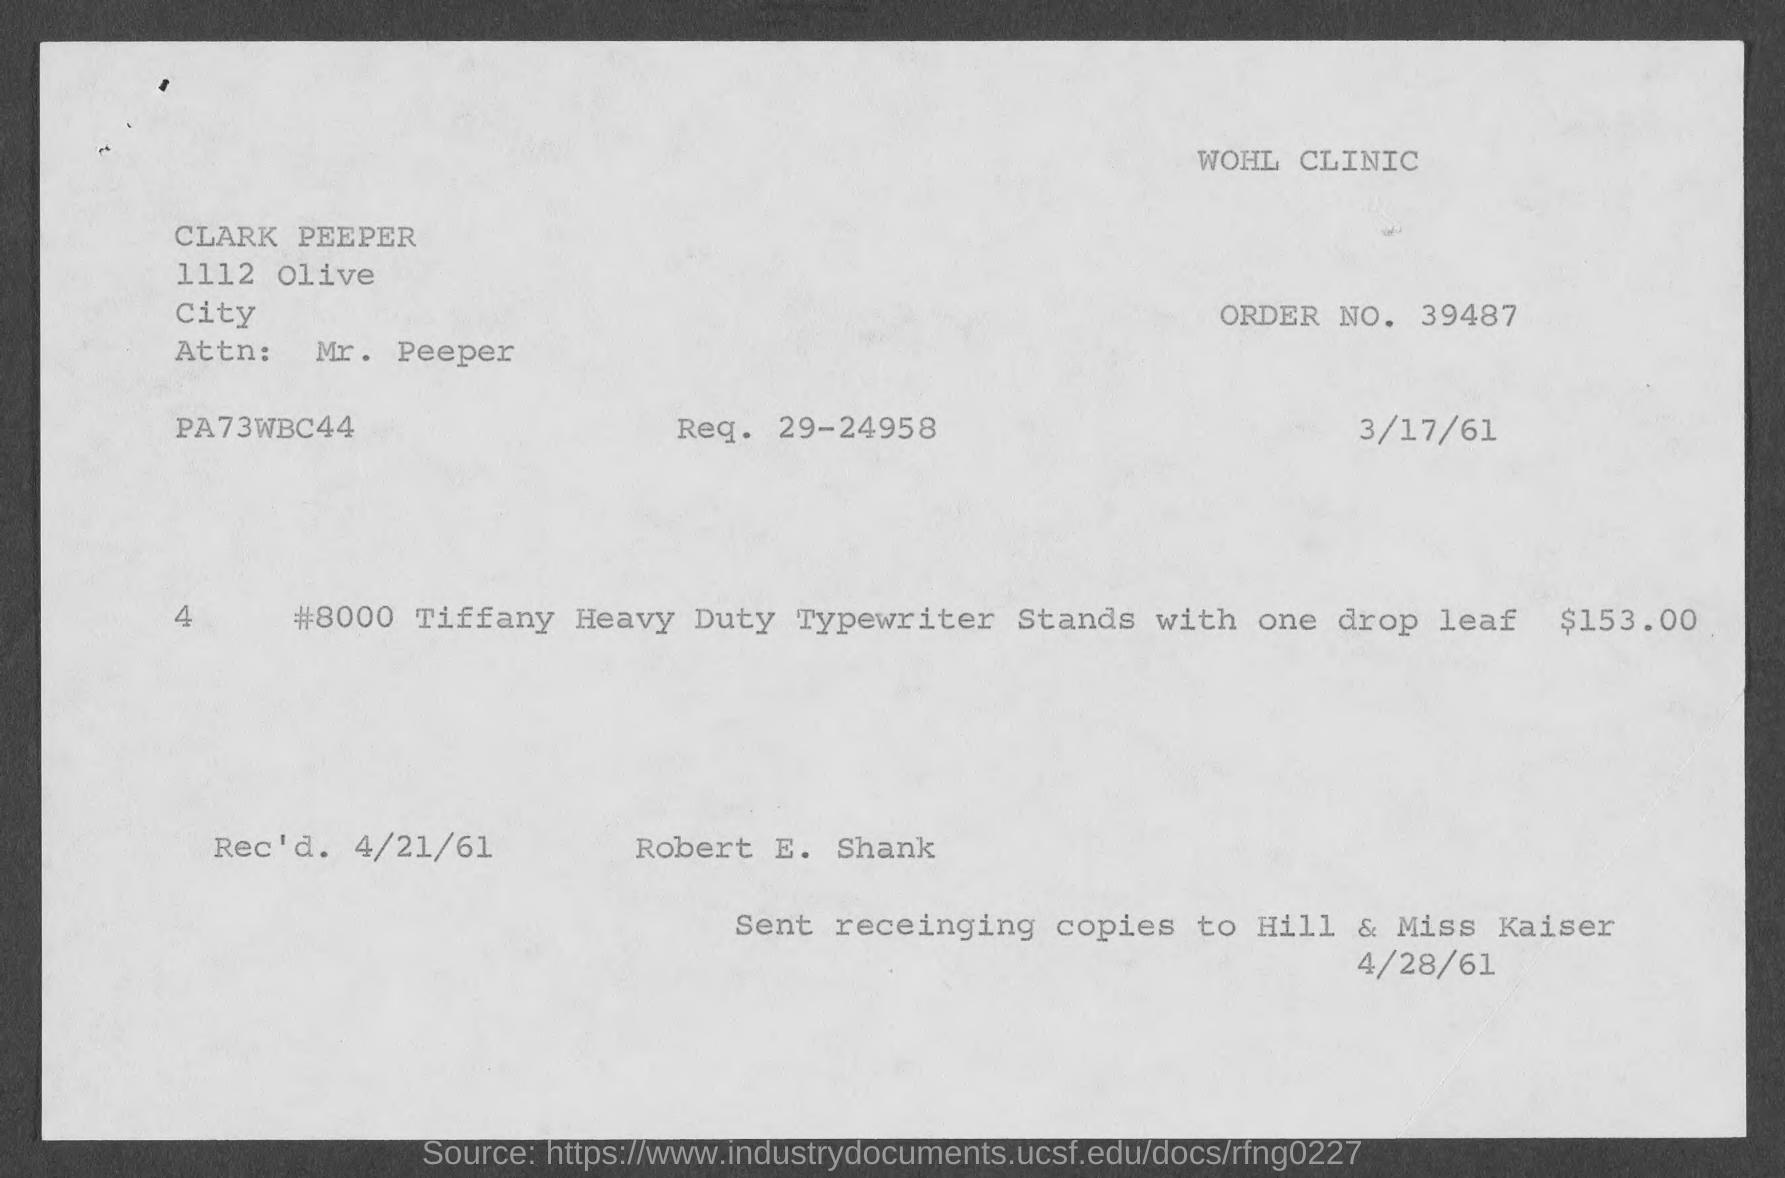What is the order no. mentioned in the given page ?
Your answer should be compact. 39487. What is the req. no. mentioned in the given page ?
Give a very brief answer. 29-24958. What is the name of the attn: mentioned in the given page ?
Ensure brevity in your answer.  Mr. peeper. What is the amount mentioned in the given form ?
Your answer should be compact. $153.00. What is the rec'd date mentioned in the given page ?
Your answer should be very brief. 4/21/61. 